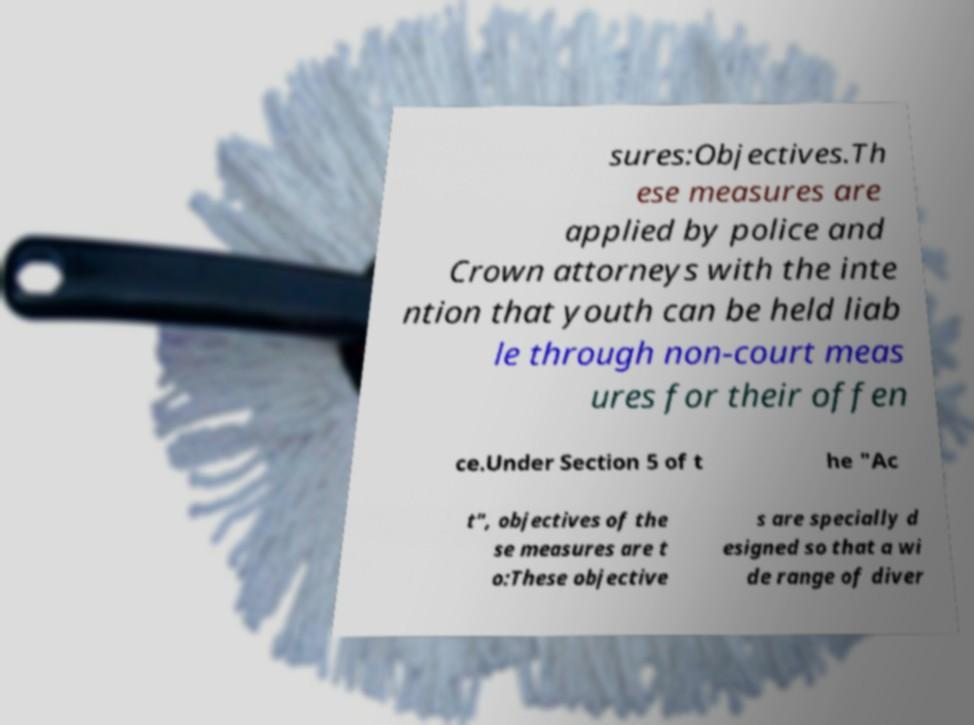Can you read and provide the text displayed in the image?This photo seems to have some interesting text. Can you extract and type it out for me? sures:Objectives.Th ese measures are applied by police and Crown attorneys with the inte ntion that youth can be held liab le through non-court meas ures for their offen ce.Under Section 5 of t he "Ac t", objectives of the se measures are t o:These objective s are specially d esigned so that a wi de range of diver 